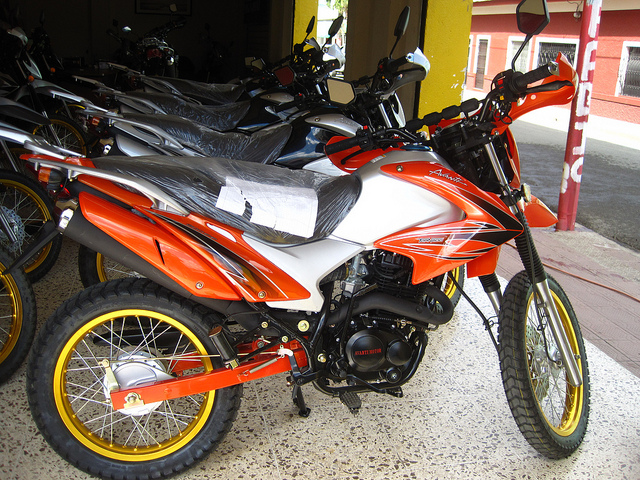Write a story where this motorcycle is a key element in a futuristic sci-fi plot. In the year 2134, Earth has become a desolate wasteland, and only a few scattered settlements remain. In this harsh new world, mobility is crucial, and the prized possession of any survivor is a reliable vehicle. Among these survivors, a young mechanic named Aria inherits a rare, perfectly maintained orange and white motorcycle from her ancestor. This motorcycle, built initially for rugged terrains, has been retrofitted with state-of-the-art technology, making it capable of traversing the most treacherous landscapes. One day, Aria discovers that her motorcycle holds a hidden map leading to a mythical oasis rumored to be the last paradise on Earth. Determined to find it, she embarks on a dangerous journey, evading rogue factions and surviving against the odds. Her motorcycle isn't just a means of transport—it becomes her trusted companion and a symbol of hope in a world devoid of dreams. What obstacles does Aria face along the way? Throughout her journey, Aria encounters numerous obstacles. She faces extreme weather conditions, from scorching heat to torrential rainstorms. The treacherous terrain tests her riding skills as she navigates through landslides and broken roads. Additionally, rogue factions, aware of the legend of the oasis, try to capture her and seize the map. Betrayal from trusted allies and dwindling resources push her to her limits. Despite these challenges, her resilience, the advanced capabilities of her motorcycle, and the friendships she builds with other survivors she meets along the way help her press on. 